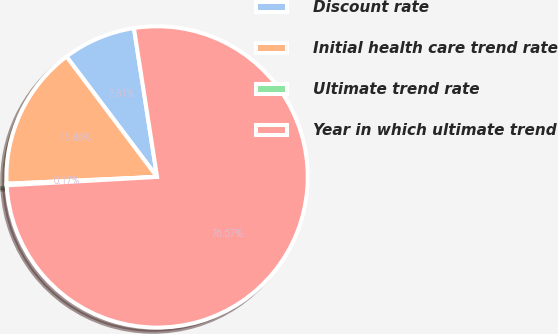Convert chart to OTSL. <chart><loc_0><loc_0><loc_500><loc_500><pie_chart><fcel>Discount rate<fcel>Initial health care trend rate<fcel>Ultimate trend rate<fcel>Year in which ultimate trend<nl><fcel>7.81%<fcel>15.45%<fcel>0.17%<fcel>76.57%<nl></chart> 